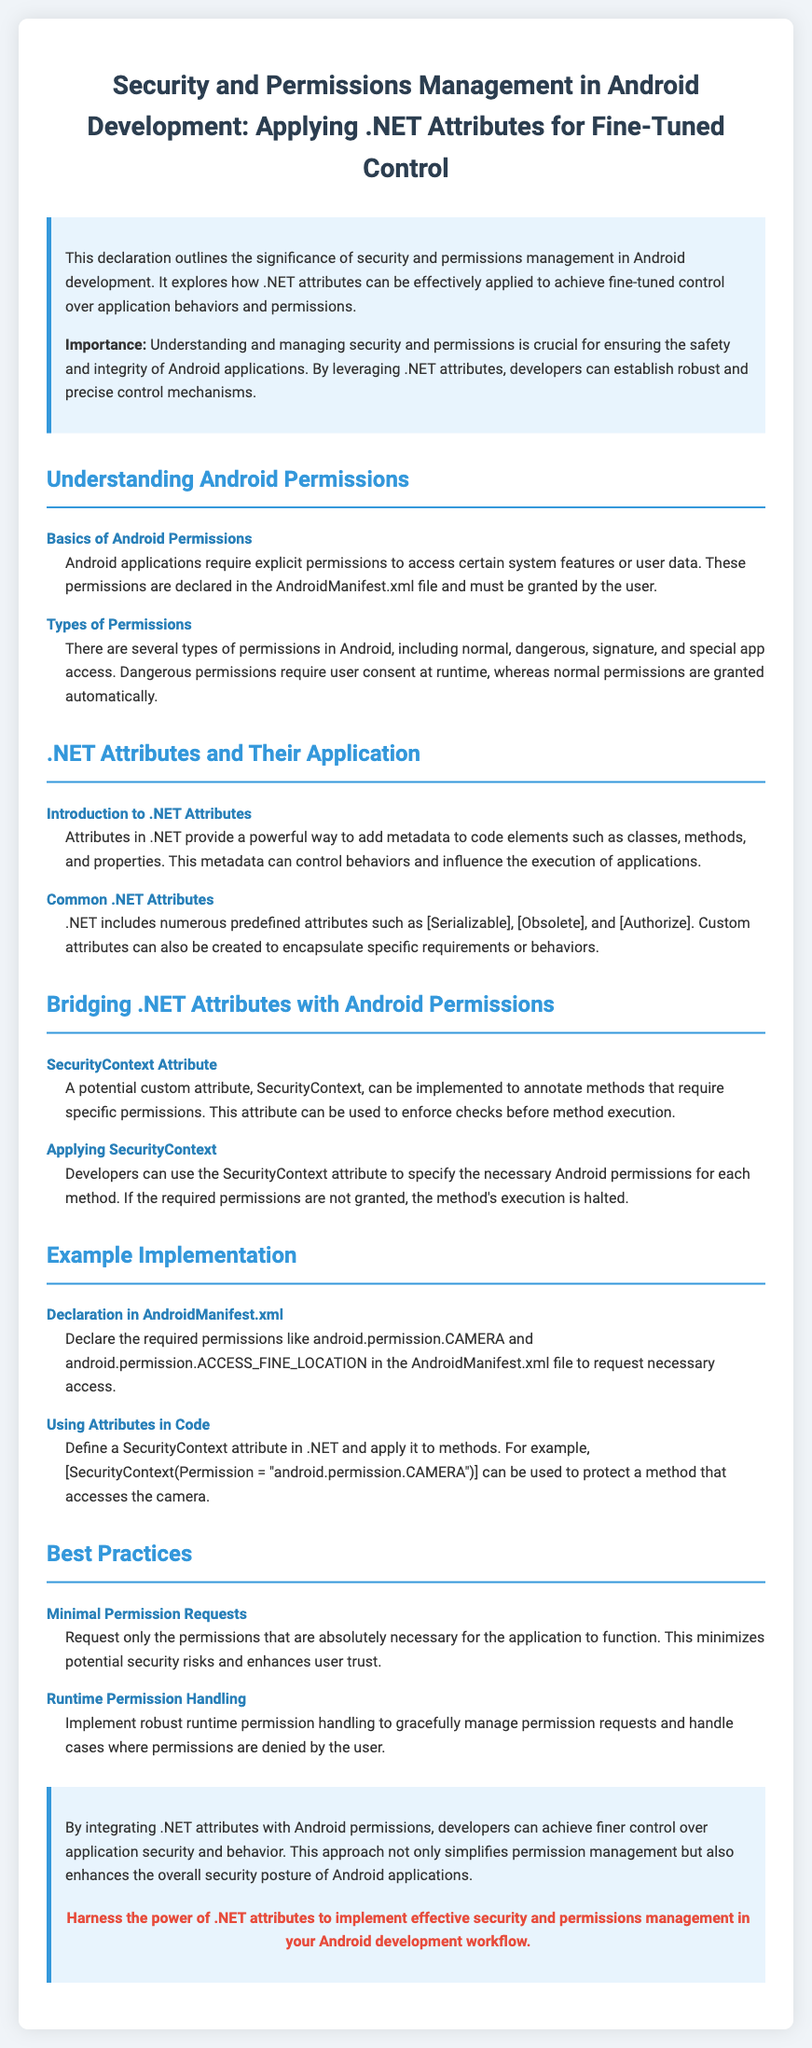What is the title of the document? The title of the document provides insight into its main focus on security and permissions management in Android development using .NET attributes.
Answer: Security and Permissions Management in Android Development: Applying .NET Attributes for Fine-Tuned Control What file declares Android permissions? This document mentions a specific file where developers declare necessary permissions for their Android applications.
Answer: AndroidManifest.xml What is the example of a dangerous permission? The document discusses types of permissions in Android, focusing on which require user consent at runtime.
Answer: Dangerous permissions What custom attribute is mentioned in the document? The text introduces a specific custom attribute that can be implemented for permission management in Android applications.
Answer: SecurityContext What is a key best practice recommended in the document? The document highlights crucial guidance for developers to minimize security risks when managing permissions.
Answer: Minimal Permission Requests How should developers apply the SecurityContext attribute? The document describes the process of applying the SecurityContext attribute in code for managing method permissions.
Answer: To specify the necessary Android permissions for each method What should be requested only when necessary according to the document? The document emphasizes on requesting a specific aspect that helps in managing security and user trust effectively.
Answer: Permissions What type of attribute allows developers to add metadata to code elements? The document details an aspect of .NET that empowers developers regarding code behavior and its execution.
Answer: Attributes 